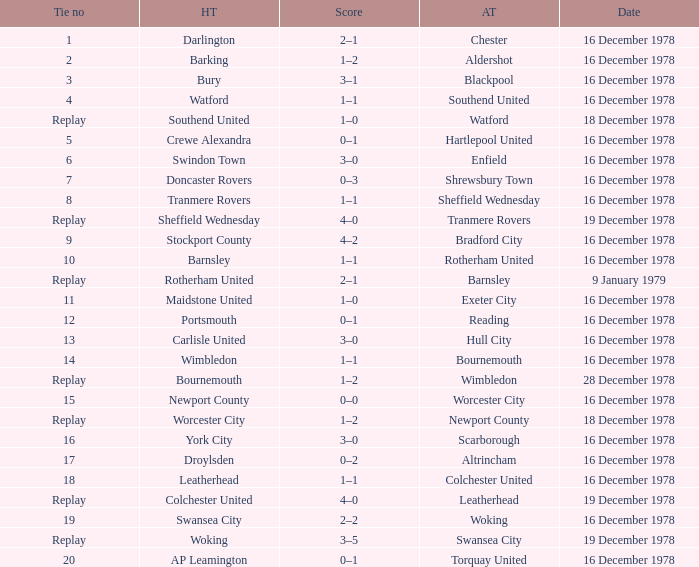What is the tie no for the away team altrincham? 17.0. 